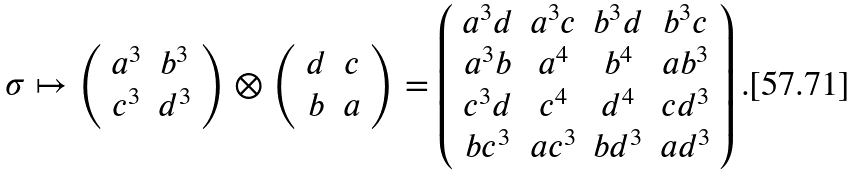Convert formula to latex. <formula><loc_0><loc_0><loc_500><loc_500>\sigma \mapsto \left ( \begin{array} { c c } a ^ { 3 } & b ^ { 3 } \\ c ^ { 3 } & d ^ { 3 } \end{array} \right ) \otimes \left ( \begin{array} { c c } d & c \\ b & a \end{array} \right ) = \left ( \begin{array} { c c c c } a ^ { 3 } d & a ^ { 3 } c & b ^ { 3 } d & b ^ { 3 } c \\ a ^ { 3 } b & a ^ { 4 } & b ^ { 4 } & a b ^ { 3 } \\ c ^ { 3 } d & c ^ { 4 } & d ^ { 4 } & c d ^ { 3 } \\ b c ^ { 3 } & a c ^ { 3 } & b d ^ { 3 } & a d ^ { 3 } \end{array} \right ) .</formula> 